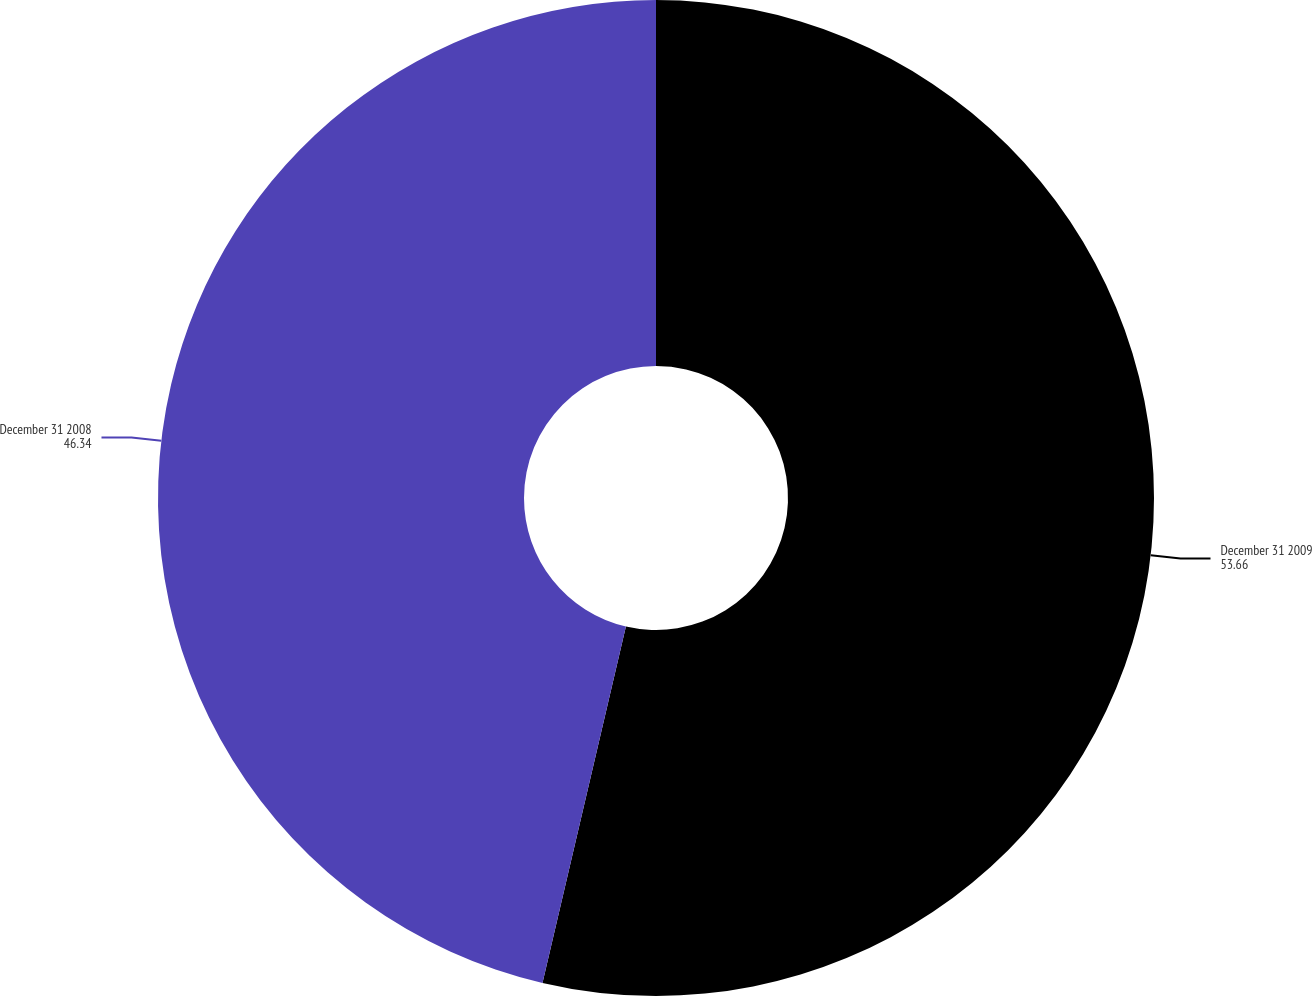Convert chart. <chart><loc_0><loc_0><loc_500><loc_500><pie_chart><fcel>December 31 2009<fcel>December 31 2008<nl><fcel>53.66%<fcel>46.34%<nl></chart> 